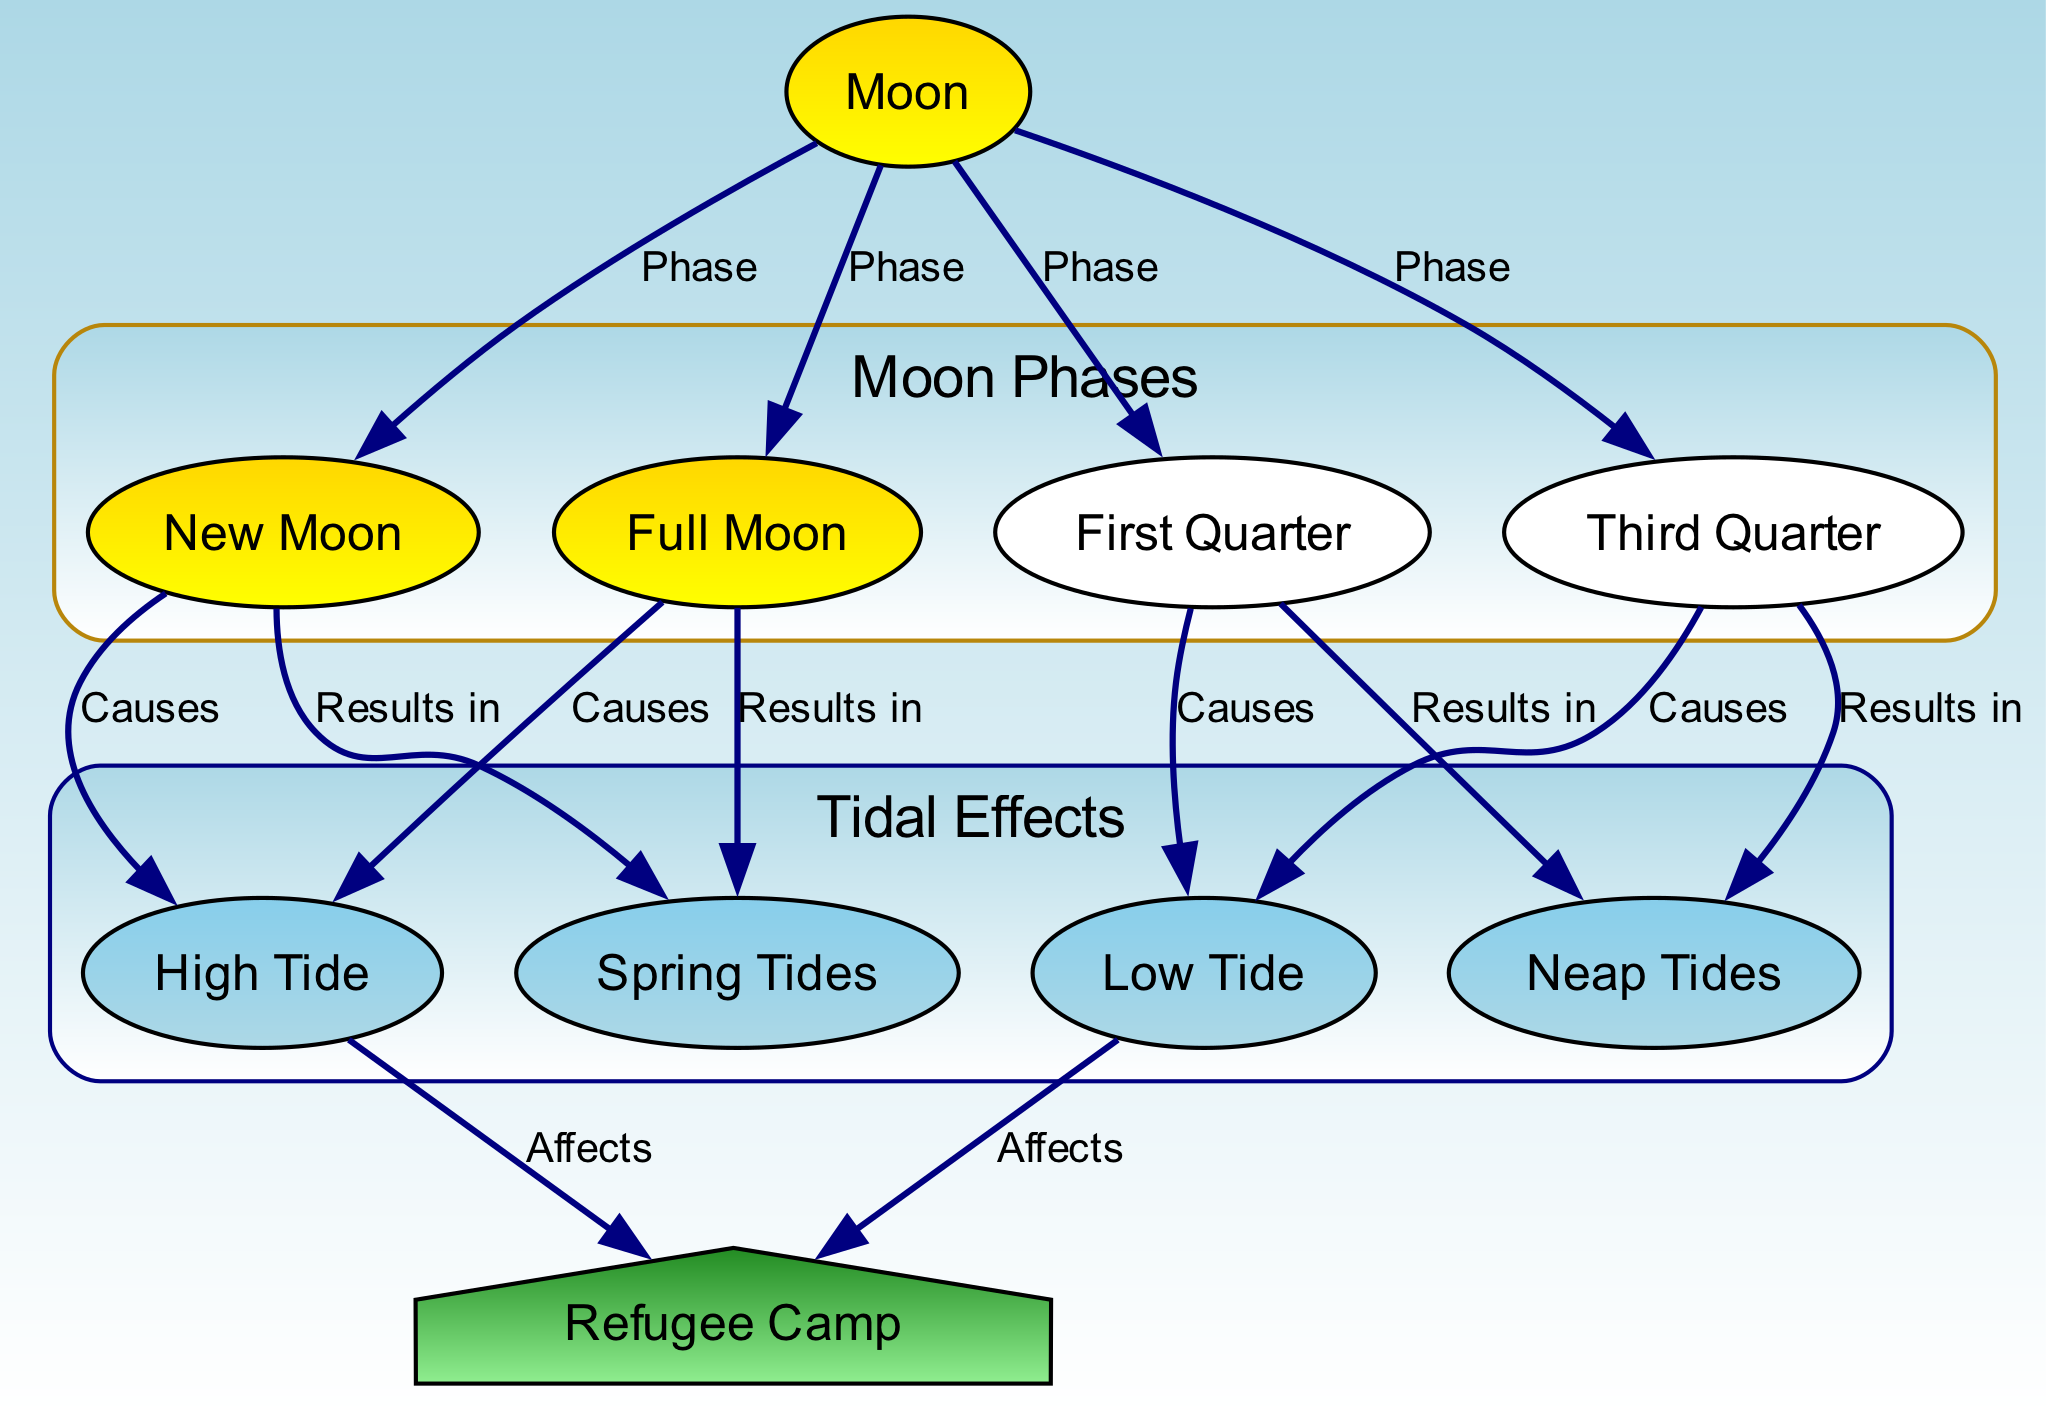What is the main influence on tidal patterns? The diagram indicates that the Moon is the primary influence on tidal patterns, showing various phases that affect the tides.
Answer: Moon What causes a High Tide according to the diagram? The diagram specifies that both New Moon and Full Moon phases result in High Tide, indicating how lunar positions correlate with tidal peaks.
Answer: New Moon and Full Moon How many phases of the Moon are depicted in the diagram? By counting the nodes associated with the Moon, we find four distinct phases explicitly mentioned: New Moon, Full Moon, First Quarter, and Third Quarter.
Answer: Four What type of tide occurs during the First Quarter phase? The diagram clearly states that the First Quarter phase results in Low Tide, showing the relationship between this lunar phase and the resulting tidal pattern.
Answer: Low Tide Which type of tides are associated with New and Full Moons? Based on the relationships shown in the diagram, it is clear that Spring Tides occur during both New and Full Moons, indicating higher high tides.
Answer: Spring Tides What effect do High Tides have on the Refugee Camp? The diagram indicates that High Tides affect the Refugee Camp, likely impacting the conditions and livability of the camp during these times.
Answer: Affects What type of tide occurs during the Third Quarter phase? In examining the diagram, it becomes evident that the Third Quarter phase results in Neap Tides, indicating lower high tides compared to Spring Tides.
Answer: Neap Tides Which lunar phase causes Spring Tides? The diagram shows that both New Moon and Full Moon phases are responsible for causing Spring Tides, emphasizing the connection between these lunar events and higher tidal levels.
Answer: New Moon and Full Moon What do Neap Tides result from? The diagram directly indicates that both the First Quarter and Third Quarter phases of the Moon result in Neap Tides, demonstrating their specific influence on tidal variations.
Answer: First Quarter and Third Quarter 